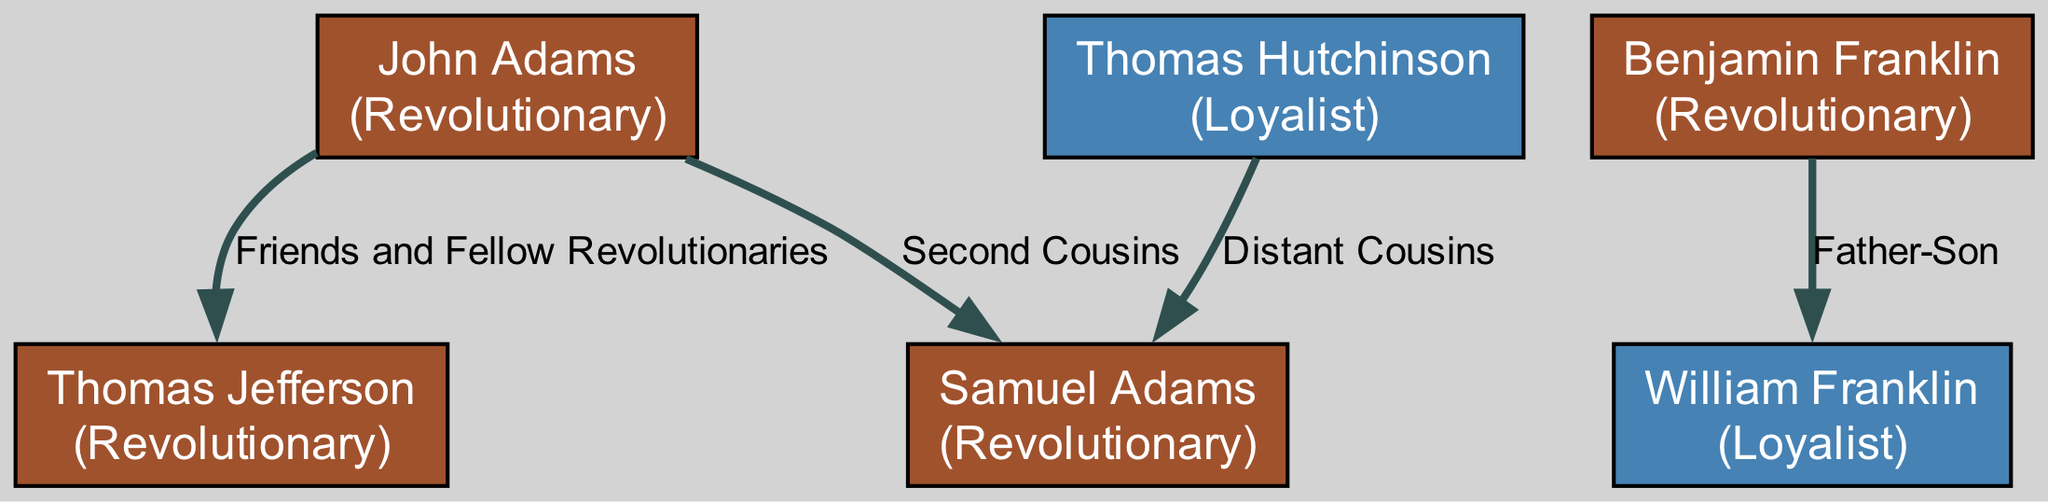What is the role of John Adams? The diagram indicates that John Adams is labeled as a "Revolutionary."
Answer: Revolutionary Who is Benjamin Franklin's son according to the diagram? The edges connecting Benjamin Franklin to William Franklin show a "Father-Son" relationship, indicating that William Franklin is his son.
Answer: William Franklin How many nodes are present in the diagram? By counting all the unique individuals listed as nodes in the diagram, we identify that there are a total of 6 nodes.
Answer: 6 What relationship exists between Thomas Hutchinson and Samuel Adams? The diagram indicates that Thomas Hutchinson and Samuel Adams have a "Distant Cousins" relationship, as shown by the labeled edge connecting them.
Answer: Distant Cousins How are John Adams and Thomas Jefferson connected? According to the diagram, John Adams and Thomas Jefferson are connected as "Friends and Fellow Revolutionaries," reflecting their collaborative relationship during the American Revolution.
Answer: Friends and Fellow Revolutionaries Who are the revolutionaries in the diagram? There are four revolutionaries identified in the diagram: John Adams, Samuel Adams, Benjamin Franklin, and Thomas Jefferson.
Answer: John Adams, Samuel Adams, Benjamin Franklin, Thomas Jefferson Which prominent figure in the diagram is labeled as a loyalist? William Franklin and Thomas Hutchinson are the two individuals identified as loyalists in the diagram.
Answer: William Franklin, Thomas Hutchinson What is the total number of edges in the diagram? By counting the connections (edges) between nodes, the diagram shows a total of 4 edges linking the individuals.
Answer: 4 Who has a direct familial tie to both a revolutionary and a loyalist? The diagram shows William Franklin as the son of Benjamin Franklin (a Revolutionary) and also categorizes him as a Loyalist, highlighting his ties to both sides.
Answer: William Franklin 